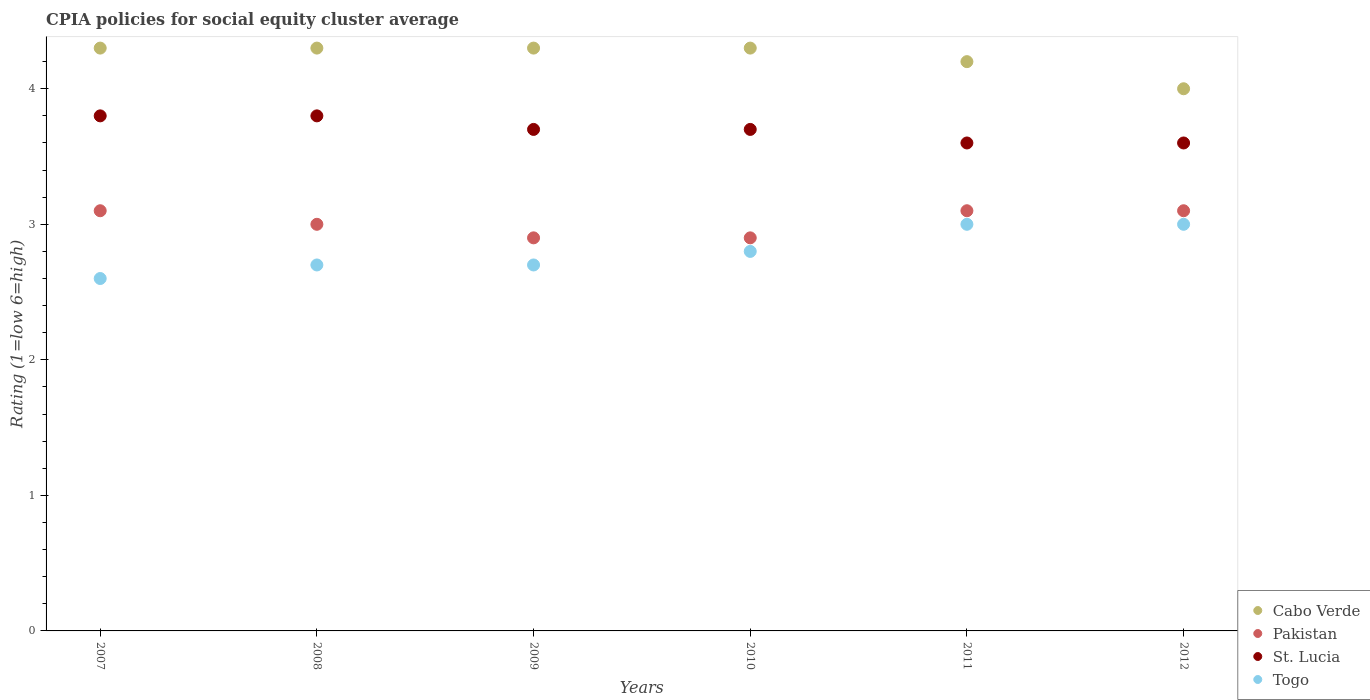How many different coloured dotlines are there?
Give a very brief answer. 4. Is the number of dotlines equal to the number of legend labels?
Provide a short and direct response. Yes. Across all years, what is the maximum CPIA rating in Pakistan?
Give a very brief answer. 3.1. What is the total CPIA rating in Cabo Verde in the graph?
Provide a short and direct response. 25.4. What is the difference between the CPIA rating in Cabo Verde in 2011 and the CPIA rating in Pakistan in 2008?
Make the answer very short. 1.2. What is the average CPIA rating in Pakistan per year?
Ensure brevity in your answer.  3.02. In the year 2008, what is the difference between the CPIA rating in Togo and CPIA rating in St. Lucia?
Give a very brief answer. -1.1. What is the ratio of the CPIA rating in Togo in 2007 to that in 2011?
Your response must be concise. 0.87. What is the difference between the highest and the lowest CPIA rating in Pakistan?
Give a very brief answer. 0.2. Is it the case that in every year, the sum of the CPIA rating in Cabo Verde and CPIA rating in Pakistan  is greater than the CPIA rating in Togo?
Provide a short and direct response. Yes. Does the CPIA rating in Togo monotonically increase over the years?
Your answer should be very brief. No. What is the difference between two consecutive major ticks on the Y-axis?
Provide a succinct answer. 1. Does the graph contain any zero values?
Ensure brevity in your answer.  No. Does the graph contain grids?
Provide a short and direct response. No. Where does the legend appear in the graph?
Ensure brevity in your answer.  Bottom right. How many legend labels are there?
Your answer should be very brief. 4. What is the title of the graph?
Make the answer very short. CPIA policies for social equity cluster average. Does "Latin America(developing only)" appear as one of the legend labels in the graph?
Offer a terse response. No. What is the label or title of the Y-axis?
Keep it short and to the point. Rating (1=low 6=high). What is the Rating (1=low 6=high) of Pakistan in 2007?
Offer a very short reply. 3.1. What is the Rating (1=low 6=high) of Cabo Verde in 2008?
Offer a very short reply. 4.3. What is the Rating (1=low 6=high) of Pakistan in 2008?
Give a very brief answer. 3. What is the Rating (1=low 6=high) of Togo in 2008?
Make the answer very short. 2.7. What is the Rating (1=low 6=high) of Togo in 2010?
Provide a succinct answer. 2.8. What is the Rating (1=low 6=high) of Cabo Verde in 2011?
Give a very brief answer. 4.2. What is the Rating (1=low 6=high) of Togo in 2011?
Give a very brief answer. 3. What is the Rating (1=low 6=high) in St. Lucia in 2012?
Ensure brevity in your answer.  3.6. Across all years, what is the maximum Rating (1=low 6=high) of Pakistan?
Provide a short and direct response. 3.1. Across all years, what is the maximum Rating (1=low 6=high) of St. Lucia?
Your answer should be very brief. 3.8. Across all years, what is the minimum Rating (1=low 6=high) of Cabo Verde?
Offer a terse response. 4. Across all years, what is the minimum Rating (1=low 6=high) in Pakistan?
Ensure brevity in your answer.  2.9. What is the total Rating (1=low 6=high) of Cabo Verde in the graph?
Your answer should be compact. 25.4. What is the total Rating (1=low 6=high) of Pakistan in the graph?
Provide a succinct answer. 18.1. What is the total Rating (1=low 6=high) in St. Lucia in the graph?
Make the answer very short. 22.2. What is the difference between the Rating (1=low 6=high) of St. Lucia in 2007 and that in 2009?
Offer a very short reply. 0.1. What is the difference between the Rating (1=low 6=high) in Togo in 2007 and that in 2009?
Provide a succinct answer. -0.1. What is the difference between the Rating (1=low 6=high) in Togo in 2007 and that in 2010?
Your answer should be compact. -0.2. What is the difference between the Rating (1=low 6=high) of St. Lucia in 2007 and that in 2011?
Your answer should be compact. 0.2. What is the difference between the Rating (1=low 6=high) of Pakistan in 2007 and that in 2012?
Provide a succinct answer. 0. What is the difference between the Rating (1=low 6=high) of Togo in 2007 and that in 2012?
Provide a succinct answer. -0.4. What is the difference between the Rating (1=low 6=high) in Cabo Verde in 2008 and that in 2009?
Keep it short and to the point. 0. What is the difference between the Rating (1=low 6=high) in St. Lucia in 2008 and that in 2009?
Provide a short and direct response. 0.1. What is the difference between the Rating (1=low 6=high) of Cabo Verde in 2008 and that in 2010?
Make the answer very short. 0. What is the difference between the Rating (1=low 6=high) in St. Lucia in 2008 and that in 2010?
Give a very brief answer. 0.1. What is the difference between the Rating (1=low 6=high) in Togo in 2008 and that in 2010?
Ensure brevity in your answer.  -0.1. What is the difference between the Rating (1=low 6=high) of Cabo Verde in 2008 and that in 2011?
Your answer should be very brief. 0.1. What is the difference between the Rating (1=low 6=high) of St. Lucia in 2008 and that in 2011?
Your answer should be compact. 0.2. What is the difference between the Rating (1=low 6=high) in Cabo Verde in 2008 and that in 2012?
Make the answer very short. 0.3. What is the difference between the Rating (1=low 6=high) of Togo in 2008 and that in 2012?
Your response must be concise. -0.3. What is the difference between the Rating (1=low 6=high) of Pakistan in 2009 and that in 2010?
Keep it short and to the point. 0. What is the difference between the Rating (1=low 6=high) in Togo in 2009 and that in 2010?
Your answer should be very brief. -0.1. What is the difference between the Rating (1=low 6=high) of Cabo Verde in 2009 and that in 2011?
Give a very brief answer. 0.1. What is the difference between the Rating (1=low 6=high) in Pakistan in 2009 and that in 2011?
Provide a short and direct response. -0.2. What is the difference between the Rating (1=low 6=high) of St. Lucia in 2009 and that in 2011?
Make the answer very short. 0.1. What is the difference between the Rating (1=low 6=high) of Togo in 2009 and that in 2011?
Offer a terse response. -0.3. What is the difference between the Rating (1=low 6=high) in Pakistan in 2009 and that in 2012?
Offer a very short reply. -0.2. What is the difference between the Rating (1=low 6=high) of St. Lucia in 2009 and that in 2012?
Your answer should be very brief. 0.1. What is the difference between the Rating (1=low 6=high) in Cabo Verde in 2011 and that in 2012?
Your answer should be very brief. 0.2. What is the difference between the Rating (1=low 6=high) in St. Lucia in 2011 and that in 2012?
Keep it short and to the point. 0. What is the difference between the Rating (1=low 6=high) in Togo in 2011 and that in 2012?
Your answer should be compact. 0. What is the difference between the Rating (1=low 6=high) of Cabo Verde in 2007 and the Rating (1=low 6=high) of Pakistan in 2008?
Ensure brevity in your answer.  1.3. What is the difference between the Rating (1=low 6=high) of Cabo Verde in 2007 and the Rating (1=low 6=high) of St. Lucia in 2008?
Ensure brevity in your answer.  0.5. What is the difference between the Rating (1=low 6=high) in Pakistan in 2007 and the Rating (1=low 6=high) in St. Lucia in 2008?
Ensure brevity in your answer.  -0.7. What is the difference between the Rating (1=low 6=high) in Pakistan in 2007 and the Rating (1=low 6=high) in Togo in 2008?
Give a very brief answer. 0.4. What is the difference between the Rating (1=low 6=high) in St. Lucia in 2007 and the Rating (1=low 6=high) in Togo in 2008?
Keep it short and to the point. 1.1. What is the difference between the Rating (1=low 6=high) in Cabo Verde in 2007 and the Rating (1=low 6=high) in Pakistan in 2009?
Give a very brief answer. 1.4. What is the difference between the Rating (1=low 6=high) of Cabo Verde in 2007 and the Rating (1=low 6=high) of Togo in 2009?
Offer a terse response. 1.6. What is the difference between the Rating (1=low 6=high) in St. Lucia in 2007 and the Rating (1=low 6=high) in Togo in 2009?
Make the answer very short. 1.1. What is the difference between the Rating (1=low 6=high) in Cabo Verde in 2007 and the Rating (1=low 6=high) in St. Lucia in 2010?
Your answer should be compact. 0.6. What is the difference between the Rating (1=low 6=high) of Pakistan in 2007 and the Rating (1=low 6=high) of St. Lucia in 2010?
Make the answer very short. -0.6. What is the difference between the Rating (1=low 6=high) in Cabo Verde in 2007 and the Rating (1=low 6=high) in Pakistan in 2011?
Make the answer very short. 1.2. What is the difference between the Rating (1=low 6=high) in Cabo Verde in 2007 and the Rating (1=low 6=high) in St. Lucia in 2011?
Your response must be concise. 0.7. What is the difference between the Rating (1=low 6=high) in Cabo Verde in 2007 and the Rating (1=low 6=high) in Togo in 2011?
Provide a short and direct response. 1.3. What is the difference between the Rating (1=low 6=high) of Pakistan in 2007 and the Rating (1=low 6=high) of Togo in 2011?
Make the answer very short. 0.1. What is the difference between the Rating (1=low 6=high) in Cabo Verde in 2007 and the Rating (1=low 6=high) in St. Lucia in 2012?
Ensure brevity in your answer.  0.7. What is the difference between the Rating (1=low 6=high) in Pakistan in 2007 and the Rating (1=low 6=high) in Togo in 2012?
Provide a short and direct response. 0.1. What is the difference between the Rating (1=low 6=high) of Cabo Verde in 2008 and the Rating (1=low 6=high) of St. Lucia in 2009?
Offer a terse response. 0.6. What is the difference between the Rating (1=low 6=high) of Cabo Verde in 2008 and the Rating (1=low 6=high) of Togo in 2009?
Your answer should be compact. 1.6. What is the difference between the Rating (1=low 6=high) in Pakistan in 2008 and the Rating (1=low 6=high) in St. Lucia in 2009?
Offer a terse response. -0.7. What is the difference between the Rating (1=low 6=high) of St. Lucia in 2008 and the Rating (1=low 6=high) of Togo in 2009?
Your answer should be very brief. 1.1. What is the difference between the Rating (1=low 6=high) in Cabo Verde in 2008 and the Rating (1=low 6=high) in Pakistan in 2010?
Offer a terse response. 1.4. What is the difference between the Rating (1=low 6=high) of Cabo Verde in 2008 and the Rating (1=low 6=high) of St. Lucia in 2010?
Give a very brief answer. 0.6. What is the difference between the Rating (1=low 6=high) of Pakistan in 2008 and the Rating (1=low 6=high) of St. Lucia in 2010?
Your response must be concise. -0.7. What is the difference between the Rating (1=low 6=high) of St. Lucia in 2008 and the Rating (1=low 6=high) of Togo in 2010?
Provide a succinct answer. 1. What is the difference between the Rating (1=low 6=high) in Cabo Verde in 2008 and the Rating (1=low 6=high) in Pakistan in 2011?
Offer a terse response. 1.2. What is the difference between the Rating (1=low 6=high) of Cabo Verde in 2008 and the Rating (1=low 6=high) of St. Lucia in 2011?
Give a very brief answer. 0.7. What is the difference between the Rating (1=low 6=high) in Cabo Verde in 2008 and the Rating (1=low 6=high) in Togo in 2011?
Ensure brevity in your answer.  1.3. What is the difference between the Rating (1=low 6=high) in Pakistan in 2008 and the Rating (1=low 6=high) in Togo in 2011?
Keep it short and to the point. 0. What is the difference between the Rating (1=low 6=high) in Cabo Verde in 2008 and the Rating (1=low 6=high) in Pakistan in 2012?
Ensure brevity in your answer.  1.2. What is the difference between the Rating (1=low 6=high) of Cabo Verde in 2008 and the Rating (1=low 6=high) of St. Lucia in 2012?
Offer a very short reply. 0.7. What is the difference between the Rating (1=low 6=high) of Cabo Verde in 2008 and the Rating (1=low 6=high) of Togo in 2012?
Offer a very short reply. 1.3. What is the difference between the Rating (1=low 6=high) of Pakistan in 2008 and the Rating (1=low 6=high) of St. Lucia in 2012?
Offer a very short reply. -0.6. What is the difference between the Rating (1=low 6=high) in Pakistan in 2008 and the Rating (1=low 6=high) in Togo in 2012?
Your response must be concise. 0. What is the difference between the Rating (1=low 6=high) in Cabo Verde in 2009 and the Rating (1=low 6=high) in Togo in 2010?
Keep it short and to the point. 1.5. What is the difference between the Rating (1=low 6=high) of Pakistan in 2009 and the Rating (1=low 6=high) of Togo in 2010?
Ensure brevity in your answer.  0.1. What is the difference between the Rating (1=low 6=high) in Cabo Verde in 2009 and the Rating (1=low 6=high) in St. Lucia in 2011?
Offer a terse response. 0.7. What is the difference between the Rating (1=low 6=high) in Pakistan in 2009 and the Rating (1=low 6=high) in St. Lucia in 2011?
Make the answer very short. -0.7. What is the difference between the Rating (1=low 6=high) of Pakistan in 2009 and the Rating (1=low 6=high) of Togo in 2011?
Your answer should be compact. -0.1. What is the difference between the Rating (1=low 6=high) of Cabo Verde in 2009 and the Rating (1=low 6=high) of Togo in 2012?
Your response must be concise. 1.3. What is the difference between the Rating (1=low 6=high) in Pakistan in 2009 and the Rating (1=low 6=high) in Togo in 2012?
Make the answer very short. -0.1. What is the difference between the Rating (1=low 6=high) of St. Lucia in 2009 and the Rating (1=low 6=high) of Togo in 2012?
Make the answer very short. 0.7. What is the difference between the Rating (1=low 6=high) of Cabo Verde in 2010 and the Rating (1=low 6=high) of Pakistan in 2011?
Give a very brief answer. 1.2. What is the difference between the Rating (1=low 6=high) in Cabo Verde in 2010 and the Rating (1=low 6=high) in St. Lucia in 2011?
Provide a succinct answer. 0.7. What is the difference between the Rating (1=low 6=high) of Pakistan in 2010 and the Rating (1=low 6=high) of St. Lucia in 2011?
Ensure brevity in your answer.  -0.7. What is the difference between the Rating (1=low 6=high) of St. Lucia in 2010 and the Rating (1=low 6=high) of Togo in 2011?
Your answer should be very brief. 0.7. What is the difference between the Rating (1=low 6=high) in Cabo Verde in 2010 and the Rating (1=low 6=high) in Pakistan in 2012?
Provide a succinct answer. 1.2. What is the difference between the Rating (1=low 6=high) in Cabo Verde in 2010 and the Rating (1=low 6=high) in St. Lucia in 2012?
Offer a terse response. 0.7. What is the difference between the Rating (1=low 6=high) in Pakistan in 2010 and the Rating (1=low 6=high) in St. Lucia in 2012?
Make the answer very short. -0.7. What is the difference between the Rating (1=low 6=high) in Pakistan in 2010 and the Rating (1=low 6=high) in Togo in 2012?
Your answer should be compact. -0.1. What is the difference between the Rating (1=low 6=high) in St. Lucia in 2010 and the Rating (1=low 6=high) in Togo in 2012?
Your answer should be very brief. 0.7. What is the difference between the Rating (1=low 6=high) in Cabo Verde in 2011 and the Rating (1=low 6=high) in Togo in 2012?
Provide a succinct answer. 1.2. What is the difference between the Rating (1=low 6=high) in Pakistan in 2011 and the Rating (1=low 6=high) in St. Lucia in 2012?
Offer a very short reply. -0.5. What is the difference between the Rating (1=low 6=high) of Pakistan in 2011 and the Rating (1=low 6=high) of Togo in 2012?
Make the answer very short. 0.1. What is the difference between the Rating (1=low 6=high) in St. Lucia in 2011 and the Rating (1=low 6=high) in Togo in 2012?
Ensure brevity in your answer.  0.6. What is the average Rating (1=low 6=high) in Cabo Verde per year?
Your answer should be very brief. 4.23. What is the average Rating (1=low 6=high) in Pakistan per year?
Make the answer very short. 3.02. What is the average Rating (1=low 6=high) of Togo per year?
Offer a very short reply. 2.8. In the year 2007, what is the difference between the Rating (1=low 6=high) of Cabo Verde and Rating (1=low 6=high) of Pakistan?
Make the answer very short. 1.2. In the year 2007, what is the difference between the Rating (1=low 6=high) of Cabo Verde and Rating (1=low 6=high) of Togo?
Offer a very short reply. 1.7. In the year 2007, what is the difference between the Rating (1=low 6=high) in Pakistan and Rating (1=low 6=high) in St. Lucia?
Ensure brevity in your answer.  -0.7. In the year 2007, what is the difference between the Rating (1=low 6=high) in Pakistan and Rating (1=low 6=high) in Togo?
Make the answer very short. 0.5. In the year 2008, what is the difference between the Rating (1=low 6=high) of Cabo Verde and Rating (1=low 6=high) of Togo?
Keep it short and to the point. 1.6. In the year 2008, what is the difference between the Rating (1=low 6=high) in St. Lucia and Rating (1=low 6=high) in Togo?
Your answer should be compact. 1.1. In the year 2009, what is the difference between the Rating (1=low 6=high) of Pakistan and Rating (1=low 6=high) of St. Lucia?
Provide a succinct answer. -0.8. In the year 2009, what is the difference between the Rating (1=low 6=high) in St. Lucia and Rating (1=low 6=high) in Togo?
Ensure brevity in your answer.  1. In the year 2010, what is the difference between the Rating (1=low 6=high) in Cabo Verde and Rating (1=low 6=high) in St. Lucia?
Make the answer very short. 0.6. In the year 2010, what is the difference between the Rating (1=low 6=high) in St. Lucia and Rating (1=low 6=high) in Togo?
Your answer should be very brief. 0.9. In the year 2011, what is the difference between the Rating (1=low 6=high) of Cabo Verde and Rating (1=low 6=high) of Pakistan?
Keep it short and to the point. 1.1. In the year 2011, what is the difference between the Rating (1=low 6=high) in Cabo Verde and Rating (1=low 6=high) in St. Lucia?
Your answer should be compact. 0.6. In the year 2011, what is the difference between the Rating (1=low 6=high) of Cabo Verde and Rating (1=low 6=high) of Togo?
Provide a succinct answer. 1.2. In the year 2011, what is the difference between the Rating (1=low 6=high) in Pakistan and Rating (1=low 6=high) in St. Lucia?
Offer a very short reply. -0.5. In the year 2012, what is the difference between the Rating (1=low 6=high) of Cabo Verde and Rating (1=low 6=high) of Pakistan?
Your answer should be very brief. 0.9. In the year 2012, what is the difference between the Rating (1=low 6=high) of Cabo Verde and Rating (1=low 6=high) of St. Lucia?
Offer a terse response. 0.4. In the year 2012, what is the difference between the Rating (1=low 6=high) in Cabo Verde and Rating (1=low 6=high) in Togo?
Offer a terse response. 1. In the year 2012, what is the difference between the Rating (1=low 6=high) in Pakistan and Rating (1=low 6=high) in St. Lucia?
Provide a short and direct response. -0.5. In the year 2012, what is the difference between the Rating (1=low 6=high) in St. Lucia and Rating (1=low 6=high) in Togo?
Offer a very short reply. 0.6. What is the ratio of the Rating (1=low 6=high) of Cabo Verde in 2007 to that in 2008?
Offer a terse response. 1. What is the ratio of the Rating (1=low 6=high) of St. Lucia in 2007 to that in 2008?
Make the answer very short. 1. What is the ratio of the Rating (1=low 6=high) in Togo in 2007 to that in 2008?
Provide a short and direct response. 0.96. What is the ratio of the Rating (1=low 6=high) in Pakistan in 2007 to that in 2009?
Your response must be concise. 1.07. What is the ratio of the Rating (1=low 6=high) of St. Lucia in 2007 to that in 2009?
Your answer should be compact. 1.03. What is the ratio of the Rating (1=low 6=high) in Togo in 2007 to that in 2009?
Provide a succinct answer. 0.96. What is the ratio of the Rating (1=low 6=high) of Pakistan in 2007 to that in 2010?
Offer a very short reply. 1.07. What is the ratio of the Rating (1=low 6=high) of St. Lucia in 2007 to that in 2010?
Your response must be concise. 1.03. What is the ratio of the Rating (1=low 6=high) of Cabo Verde in 2007 to that in 2011?
Give a very brief answer. 1.02. What is the ratio of the Rating (1=low 6=high) of Pakistan in 2007 to that in 2011?
Offer a terse response. 1. What is the ratio of the Rating (1=low 6=high) in St. Lucia in 2007 to that in 2011?
Give a very brief answer. 1.06. What is the ratio of the Rating (1=low 6=high) in Togo in 2007 to that in 2011?
Make the answer very short. 0.87. What is the ratio of the Rating (1=low 6=high) in Cabo Verde in 2007 to that in 2012?
Ensure brevity in your answer.  1.07. What is the ratio of the Rating (1=low 6=high) of St. Lucia in 2007 to that in 2012?
Give a very brief answer. 1.06. What is the ratio of the Rating (1=low 6=high) of Togo in 2007 to that in 2012?
Make the answer very short. 0.87. What is the ratio of the Rating (1=low 6=high) in Pakistan in 2008 to that in 2009?
Your answer should be compact. 1.03. What is the ratio of the Rating (1=low 6=high) of Togo in 2008 to that in 2009?
Ensure brevity in your answer.  1. What is the ratio of the Rating (1=low 6=high) in Pakistan in 2008 to that in 2010?
Offer a terse response. 1.03. What is the ratio of the Rating (1=low 6=high) in St. Lucia in 2008 to that in 2010?
Offer a very short reply. 1.03. What is the ratio of the Rating (1=low 6=high) in Cabo Verde in 2008 to that in 2011?
Keep it short and to the point. 1.02. What is the ratio of the Rating (1=low 6=high) of Pakistan in 2008 to that in 2011?
Your answer should be compact. 0.97. What is the ratio of the Rating (1=low 6=high) of St. Lucia in 2008 to that in 2011?
Your answer should be very brief. 1.06. What is the ratio of the Rating (1=low 6=high) in Cabo Verde in 2008 to that in 2012?
Provide a succinct answer. 1.07. What is the ratio of the Rating (1=low 6=high) of Pakistan in 2008 to that in 2012?
Your answer should be compact. 0.97. What is the ratio of the Rating (1=low 6=high) in St. Lucia in 2008 to that in 2012?
Make the answer very short. 1.06. What is the ratio of the Rating (1=low 6=high) of Cabo Verde in 2009 to that in 2010?
Your answer should be compact. 1. What is the ratio of the Rating (1=low 6=high) in Pakistan in 2009 to that in 2010?
Make the answer very short. 1. What is the ratio of the Rating (1=low 6=high) in St. Lucia in 2009 to that in 2010?
Provide a short and direct response. 1. What is the ratio of the Rating (1=low 6=high) in Togo in 2009 to that in 2010?
Your answer should be compact. 0.96. What is the ratio of the Rating (1=low 6=high) of Cabo Verde in 2009 to that in 2011?
Your answer should be very brief. 1.02. What is the ratio of the Rating (1=low 6=high) in Pakistan in 2009 to that in 2011?
Give a very brief answer. 0.94. What is the ratio of the Rating (1=low 6=high) of St. Lucia in 2009 to that in 2011?
Offer a terse response. 1.03. What is the ratio of the Rating (1=low 6=high) in Togo in 2009 to that in 2011?
Your answer should be very brief. 0.9. What is the ratio of the Rating (1=low 6=high) in Cabo Verde in 2009 to that in 2012?
Ensure brevity in your answer.  1.07. What is the ratio of the Rating (1=low 6=high) in Pakistan in 2009 to that in 2012?
Your response must be concise. 0.94. What is the ratio of the Rating (1=low 6=high) of St. Lucia in 2009 to that in 2012?
Your response must be concise. 1.03. What is the ratio of the Rating (1=low 6=high) in Togo in 2009 to that in 2012?
Make the answer very short. 0.9. What is the ratio of the Rating (1=low 6=high) in Cabo Verde in 2010 to that in 2011?
Give a very brief answer. 1.02. What is the ratio of the Rating (1=low 6=high) of Pakistan in 2010 to that in 2011?
Your response must be concise. 0.94. What is the ratio of the Rating (1=low 6=high) in St. Lucia in 2010 to that in 2011?
Make the answer very short. 1.03. What is the ratio of the Rating (1=low 6=high) of Togo in 2010 to that in 2011?
Offer a very short reply. 0.93. What is the ratio of the Rating (1=low 6=high) of Cabo Verde in 2010 to that in 2012?
Ensure brevity in your answer.  1.07. What is the ratio of the Rating (1=low 6=high) of Pakistan in 2010 to that in 2012?
Your response must be concise. 0.94. What is the ratio of the Rating (1=low 6=high) of St. Lucia in 2010 to that in 2012?
Give a very brief answer. 1.03. What is the ratio of the Rating (1=low 6=high) in Togo in 2010 to that in 2012?
Offer a terse response. 0.93. What is the ratio of the Rating (1=low 6=high) of Togo in 2011 to that in 2012?
Your answer should be compact. 1. What is the difference between the highest and the second highest Rating (1=low 6=high) of St. Lucia?
Provide a short and direct response. 0. What is the difference between the highest and the second highest Rating (1=low 6=high) in Togo?
Ensure brevity in your answer.  0. 